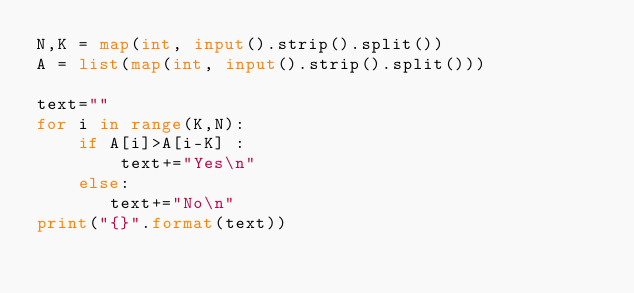Convert code to text. <code><loc_0><loc_0><loc_500><loc_500><_Python_>N,K = map(int, input().strip().split())
A = list(map(int, input().strip().split()))

text=""
for i in range(K,N):
    if A[i]>A[i-K] :
        text+="Yes\n"
    else:
       text+="No\n"
print("{}".format(text))



</code> 